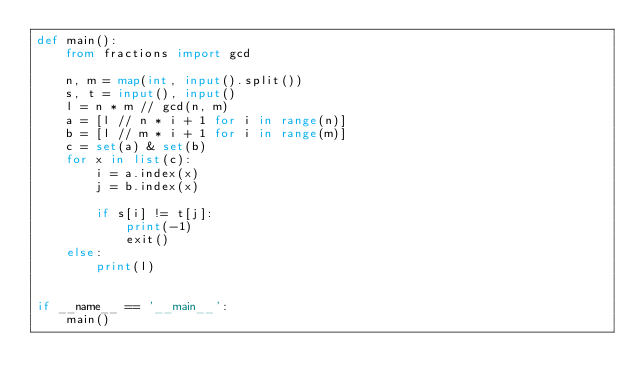<code> <loc_0><loc_0><loc_500><loc_500><_Python_>def main():
    from fractions import gcd

    n, m = map(int, input().split())
    s, t = input(), input()
    l = n * m // gcd(n, m)
    a = [l // n * i + 1 for i in range(n)]
    b = [l // m * i + 1 for i in range(m)]
    c = set(a) & set(b)
    for x in list(c):
        i = a.index(x)
        j = b.index(x)

        if s[i] != t[j]:
            print(-1)
            exit()
    else:
        print(l)


if __name__ == '__main__':
    main()
</code> 